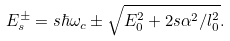Convert formula to latex. <formula><loc_0><loc_0><loc_500><loc_500>E _ { s } ^ { \pm } = s \hbar { \omega } _ { c } \pm \sqrt { E _ { 0 } ^ { 2 } + 2 s \alpha ^ { 2 } / l _ { 0 } ^ { 2 } } .</formula> 